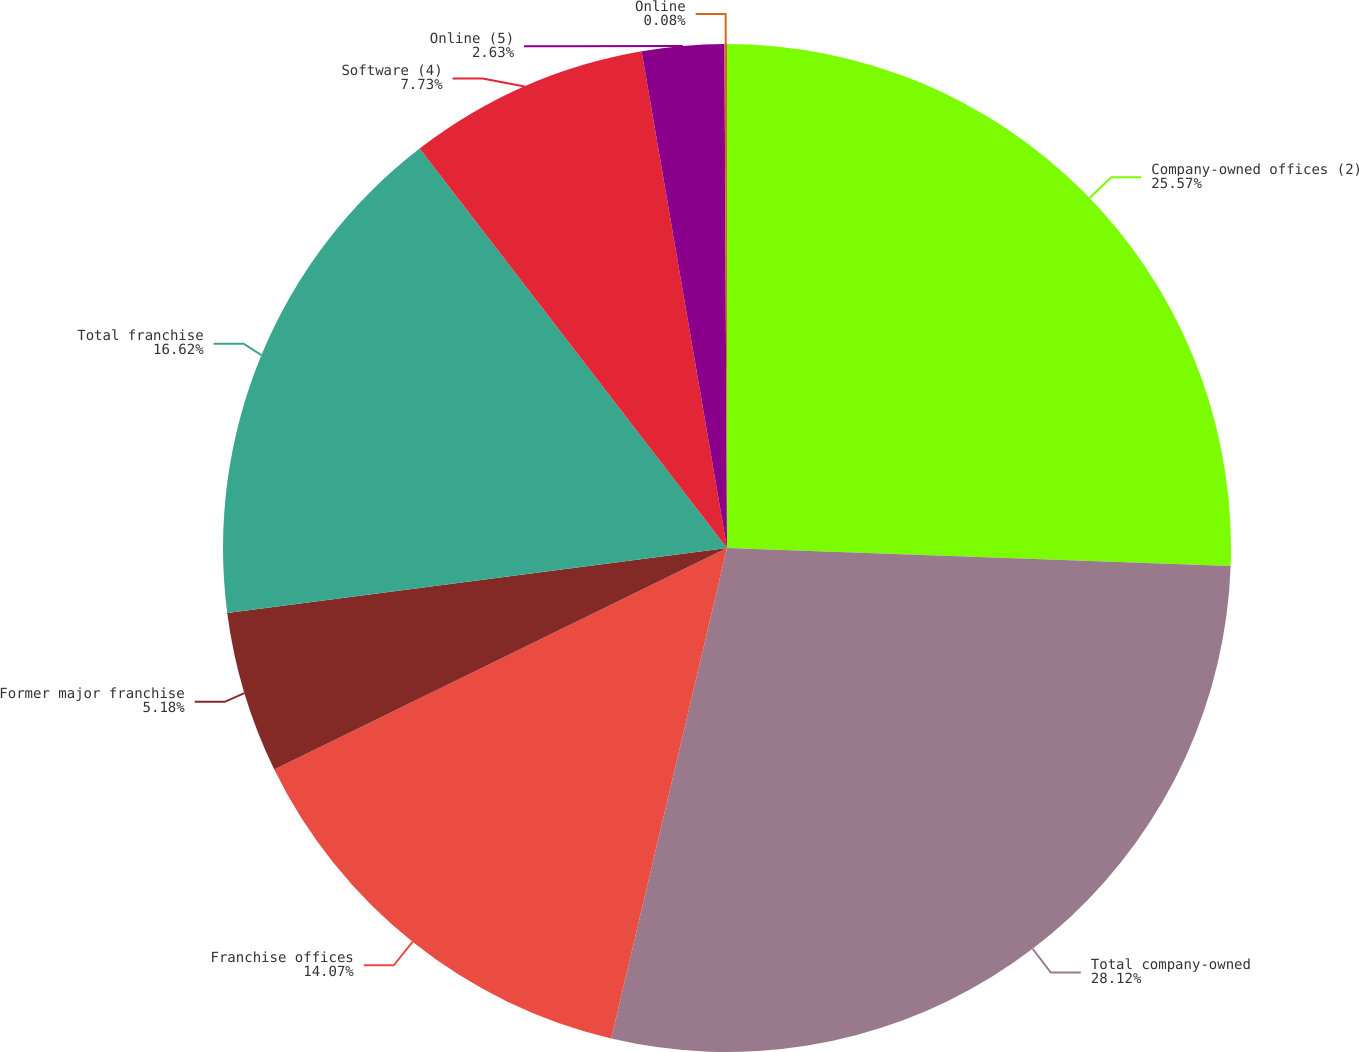Convert chart to OTSL. <chart><loc_0><loc_0><loc_500><loc_500><pie_chart><fcel>Company-owned offices (2)<fcel>Total company-owned<fcel>Franchise offices<fcel>Former major franchise<fcel>Total franchise<fcel>Software (4)<fcel>Online (5)<fcel>Online<nl><fcel>25.57%<fcel>28.12%<fcel>14.07%<fcel>5.18%<fcel>16.62%<fcel>7.73%<fcel>2.63%<fcel>0.08%<nl></chart> 